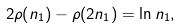Convert formula to latex. <formula><loc_0><loc_0><loc_500><loc_500>2 \rho ( n _ { 1 } ) - \rho ( 2 n _ { 1 } ) = \ln n _ { 1 } ,</formula> 